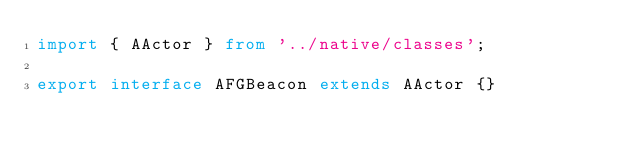Convert code to text. <code><loc_0><loc_0><loc_500><loc_500><_TypeScript_>import { AActor } from '../native/classes';

export interface AFGBeacon extends AActor {}
</code> 